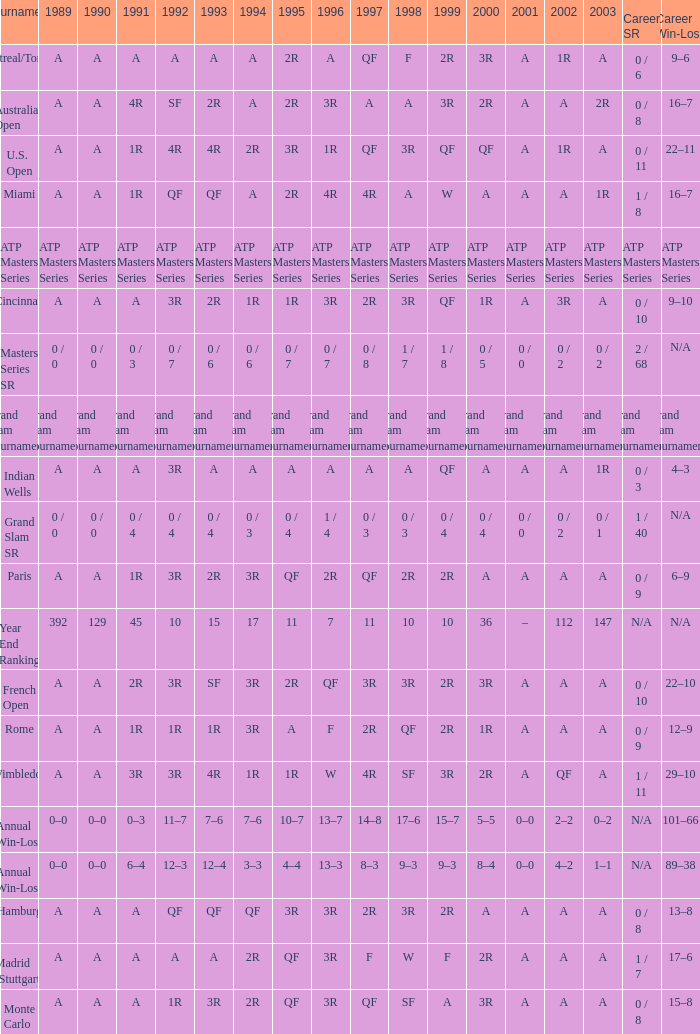What was the value in 1989 with QF in 1997 and A in 1993? A. 